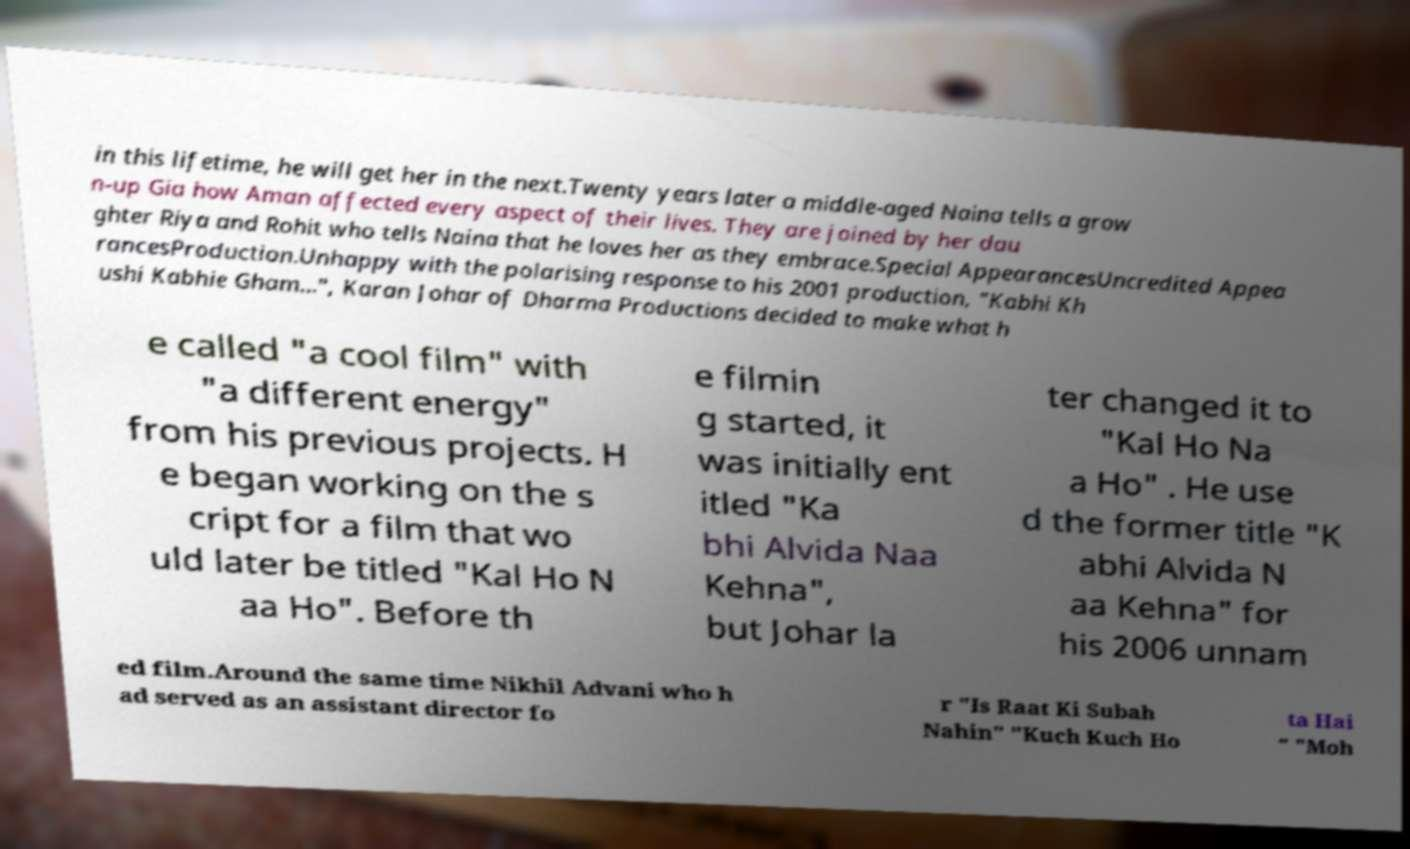Please read and relay the text visible in this image. What does it say? in this lifetime, he will get her in the next.Twenty years later a middle-aged Naina tells a grow n-up Gia how Aman affected every aspect of their lives. They are joined by her dau ghter Riya and Rohit who tells Naina that he loves her as they embrace.Special AppearancesUncredited Appea rancesProduction.Unhappy with the polarising response to his 2001 production, "Kabhi Kh ushi Kabhie Gham...", Karan Johar of Dharma Productions decided to make what h e called "a cool film" with "a different energy" from his previous projects. H e began working on the s cript for a film that wo uld later be titled "Kal Ho N aa Ho". Before th e filmin g started, it was initially ent itled "Ka bhi Alvida Naa Kehna", but Johar la ter changed it to "Kal Ho Na a Ho" . He use d the former title "K abhi Alvida N aa Kehna" for his 2006 unnam ed film.Around the same time Nikhil Advani who h ad served as an assistant director fo r "Is Raat Ki Subah Nahin" "Kuch Kuch Ho ta Hai " "Moh 